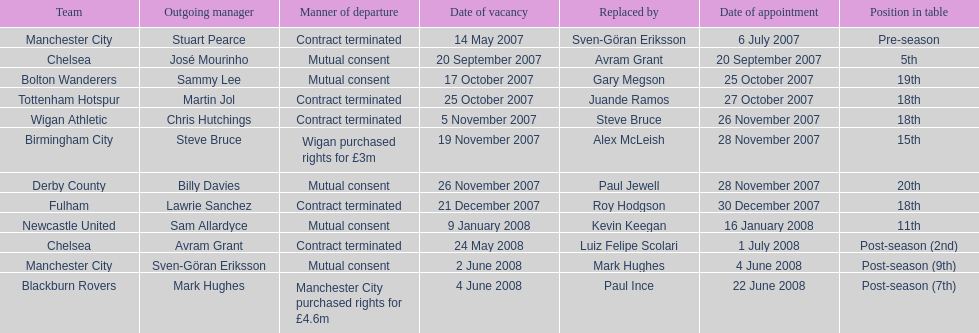How many outgoing managers were appointed in november 2007? 3. 